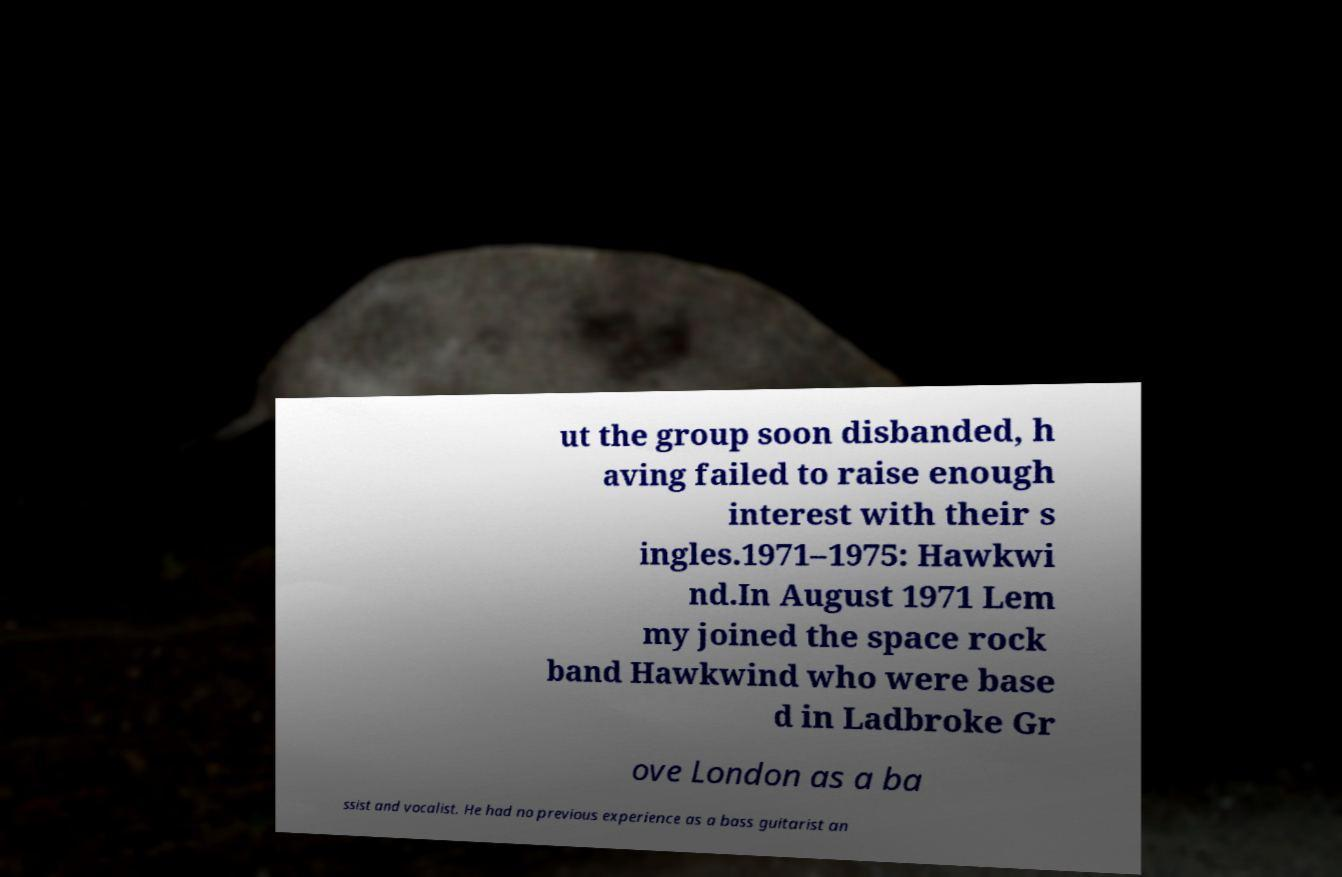I need the written content from this picture converted into text. Can you do that? ut the group soon disbanded, h aving failed to raise enough interest with their s ingles.1971–1975: Hawkwi nd.In August 1971 Lem my joined the space rock band Hawkwind who were base d in Ladbroke Gr ove London as a ba ssist and vocalist. He had no previous experience as a bass guitarist an 